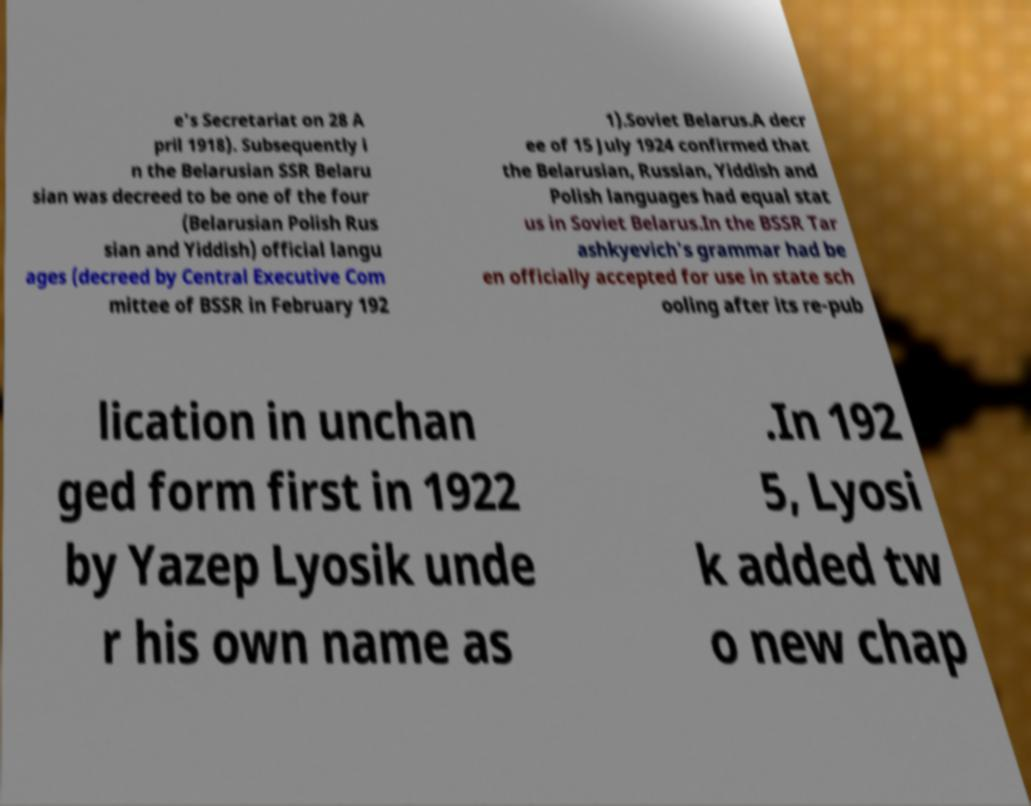Could you extract and type out the text from this image? e's Secretariat on 28 A pril 1918). Subsequently i n the Belarusian SSR Belaru sian was decreed to be one of the four (Belarusian Polish Rus sian and Yiddish) official langu ages (decreed by Central Executive Com mittee of BSSR in February 192 1).Soviet Belarus.A decr ee of 15 July 1924 confirmed that the Belarusian, Russian, Yiddish and Polish languages had equal stat us in Soviet Belarus.In the BSSR Tar ashkyevich's grammar had be en officially accepted for use in state sch ooling after its re-pub lication in unchan ged form first in 1922 by Yazep Lyosik unde r his own name as .In 192 5, Lyosi k added tw o new chap 